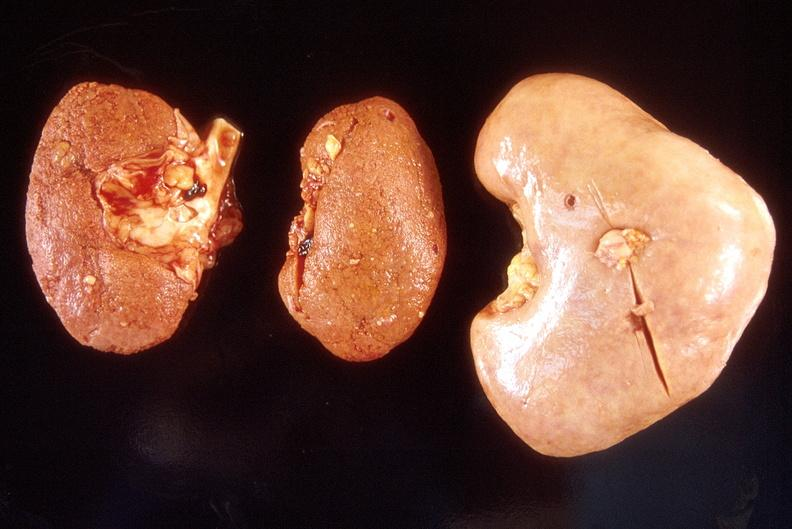does bone, skull show left - native end stage kidneys right - renal allograft abdominal?
Answer the question using a single word or phrase. No 